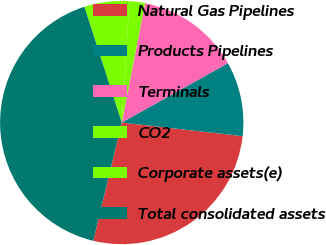Convert chart. <chart><loc_0><loc_0><loc_500><loc_500><pie_chart><fcel>Natural Gas Pipelines<fcel>Products Pipelines<fcel>Terminals<fcel>CO2<fcel>Corporate assets(e)<fcel>Total consolidated assets<nl><fcel>26.98%<fcel>9.9%<fcel>13.82%<fcel>2.06%<fcel>5.98%<fcel>41.27%<nl></chart> 